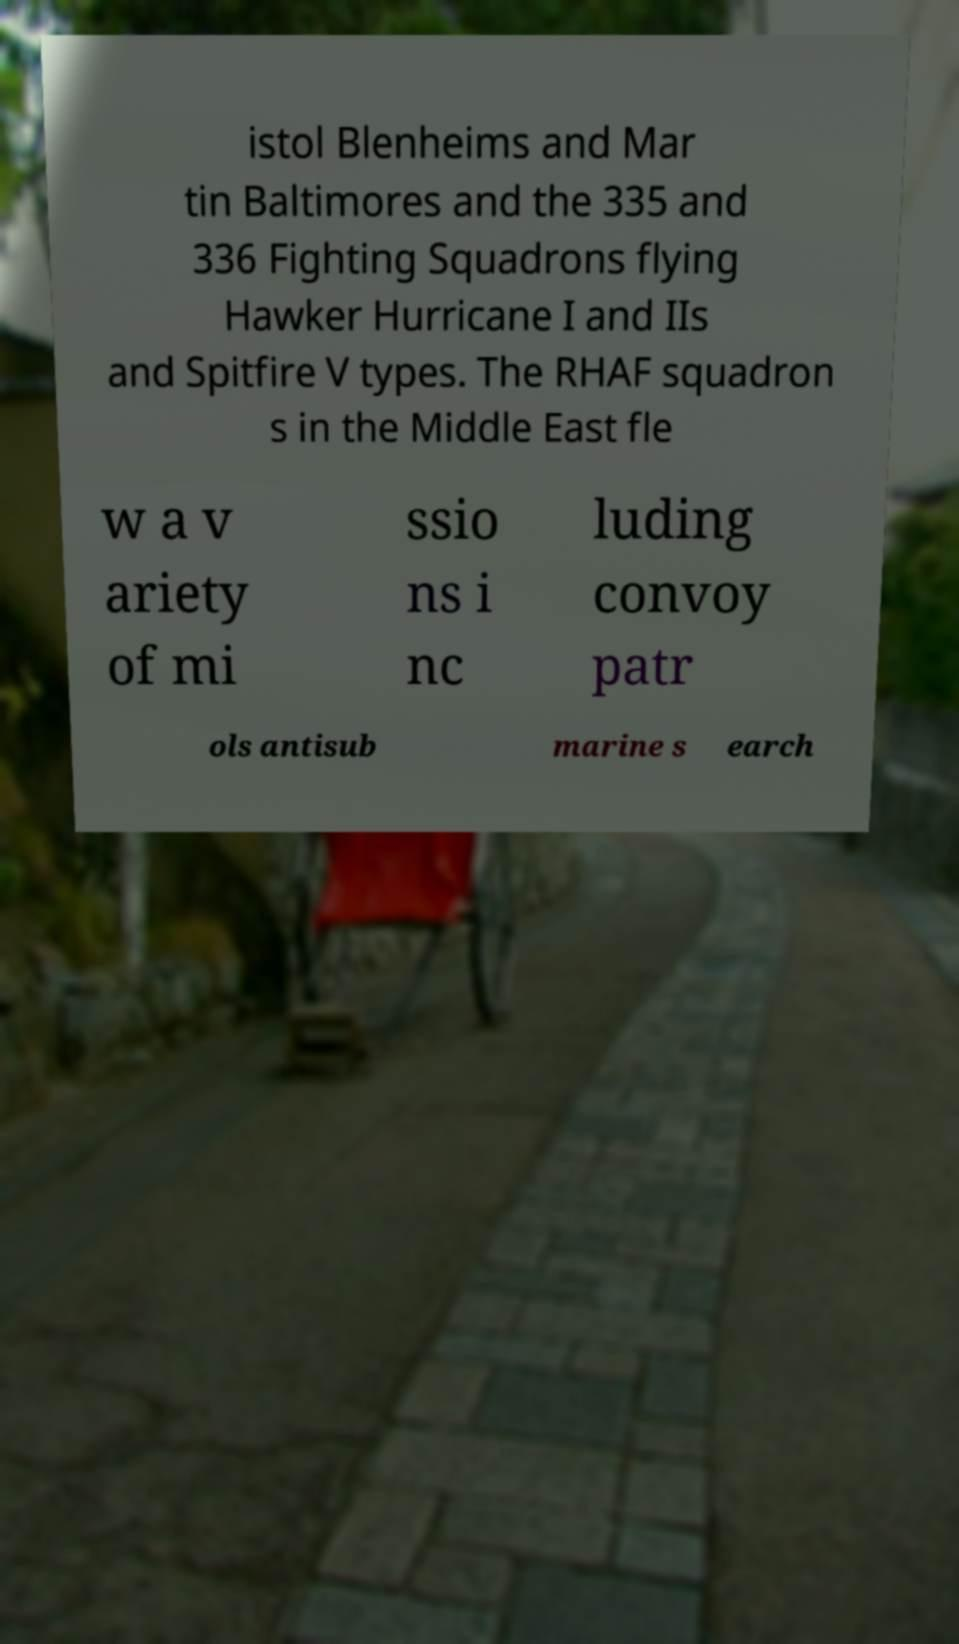Could you extract and type out the text from this image? istol Blenheims and Mar tin Baltimores and the 335 and 336 Fighting Squadrons flying Hawker Hurricane I and IIs and Spitfire V types. The RHAF squadron s in the Middle East fle w a v ariety of mi ssio ns i nc luding convoy patr ols antisub marine s earch 